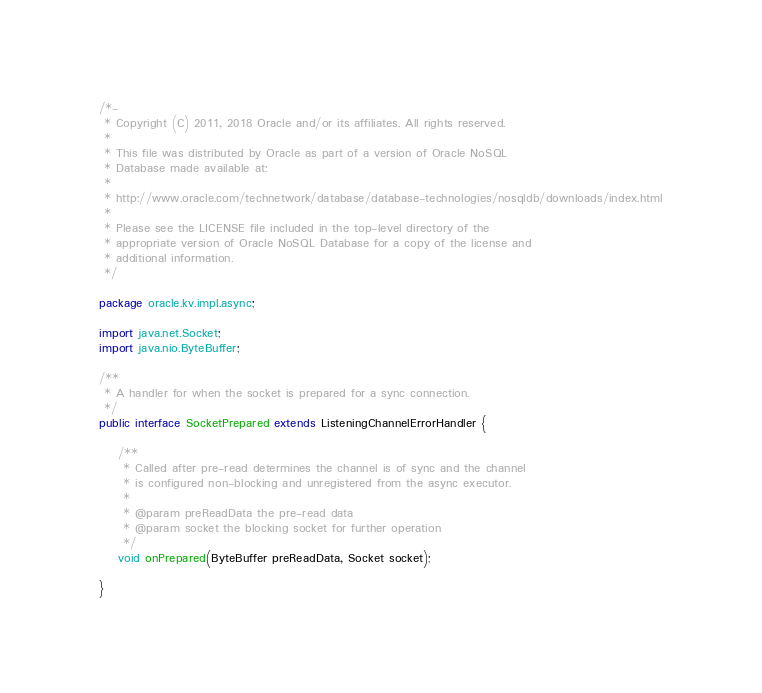Convert code to text. <code><loc_0><loc_0><loc_500><loc_500><_Java_>/*-
 * Copyright (C) 2011, 2018 Oracle and/or its affiliates. All rights reserved.
 *
 * This file was distributed by Oracle as part of a version of Oracle NoSQL
 * Database made available at:
 *
 * http://www.oracle.com/technetwork/database/database-technologies/nosqldb/downloads/index.html
 *
 * Please see the LICENSE file included in the top-level directory of the
 * appropriate version of Oracle NoSQL Database for a copy of the license and
 * additional information.
 */

package oracle.kv.impl.async;

import java.net.Socket;
import java.nio.ByteBuffer;

/**
 * A handler for when the socket is prepared for a sync connection.
 */
public interface SocketPrepared extends ListeningChannelErrorHandler {

    /**
     * Called after pre-read determines the channel is of sync and the channel
     * is configured non-blocking and unregistered from the async executor.
     *
     * @param preReadData the pre-read data
     * @param socket the blocking socket for further operation
     */
    void onPrepared(ByteBuffer preReadData, Socket socket);

}
</code> 